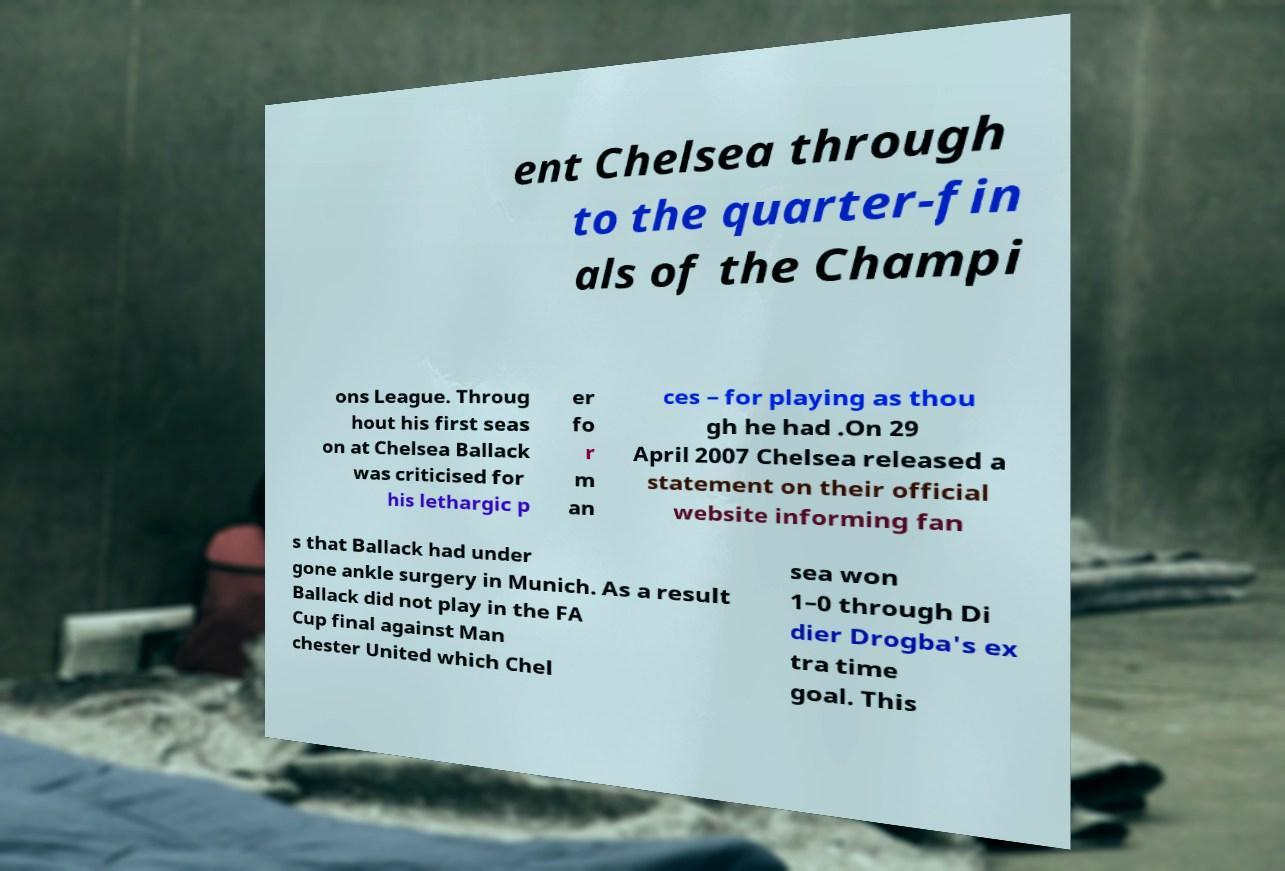Can you read and provide the text displayed in the image?This photo seems to have some interesting text. Can you extract and type it out for me? ent Chelsea through to the quarter-fin als of the Champi ons League. Throug hout his first seas on at Chelsea Ballack was criticised for his lethargic p er fo r m an ces – for playing as thou gh he had .On 29 April 2007 Chelsea released a statement on their official website informing fan s that Ballack had under gone ankle surgery in Munich. As a result Ballack did not play in the FA Cup final against Man chester United which Chel sea won 1–0 through Di dier Drogba's ex tra time goal. This 